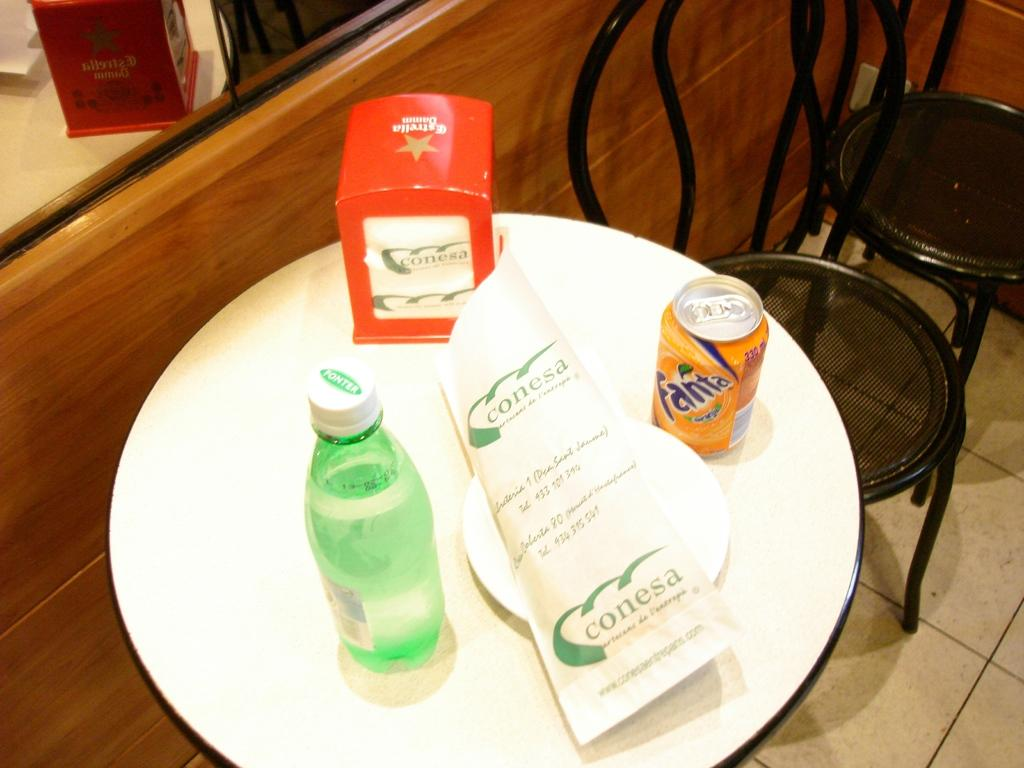<image>
Give a short and clear explanation of the subsequent image. Wrapped conesa package on a white plate next to a fanta orange soda can seated on a round white table. 